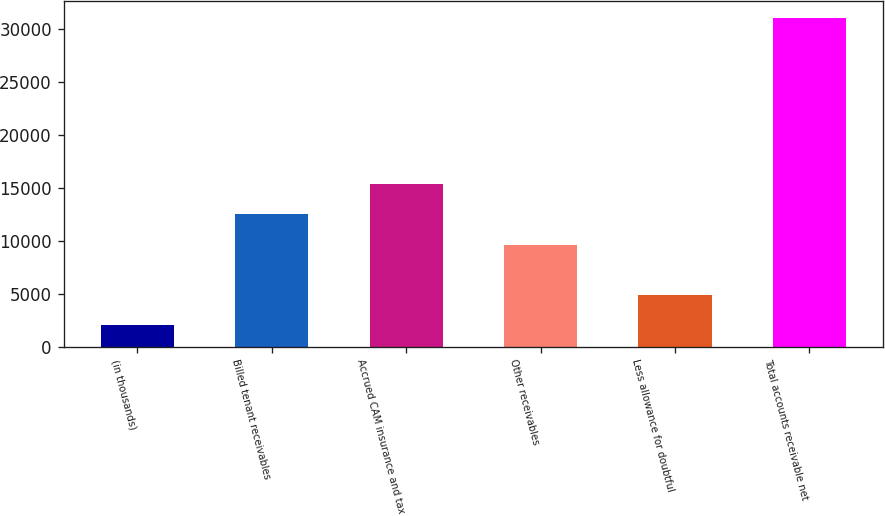Convert chart to OTSL. <chart><loc_0><loc_0><loc_500><loc_500><bar_chart><fcel>(in thousands)<fcel>Billed tenant receivables<fcel>Accrued CAM insurance and tax<fcel>Other receivables<fcel>Less allowance for doubtful<fcel>Total accounts receivable net<nl><fcel>2014<fcel>12468.5<fcel>15369<fcel>9570<fcel>4912.5<fcel>30999<nl></chart> 